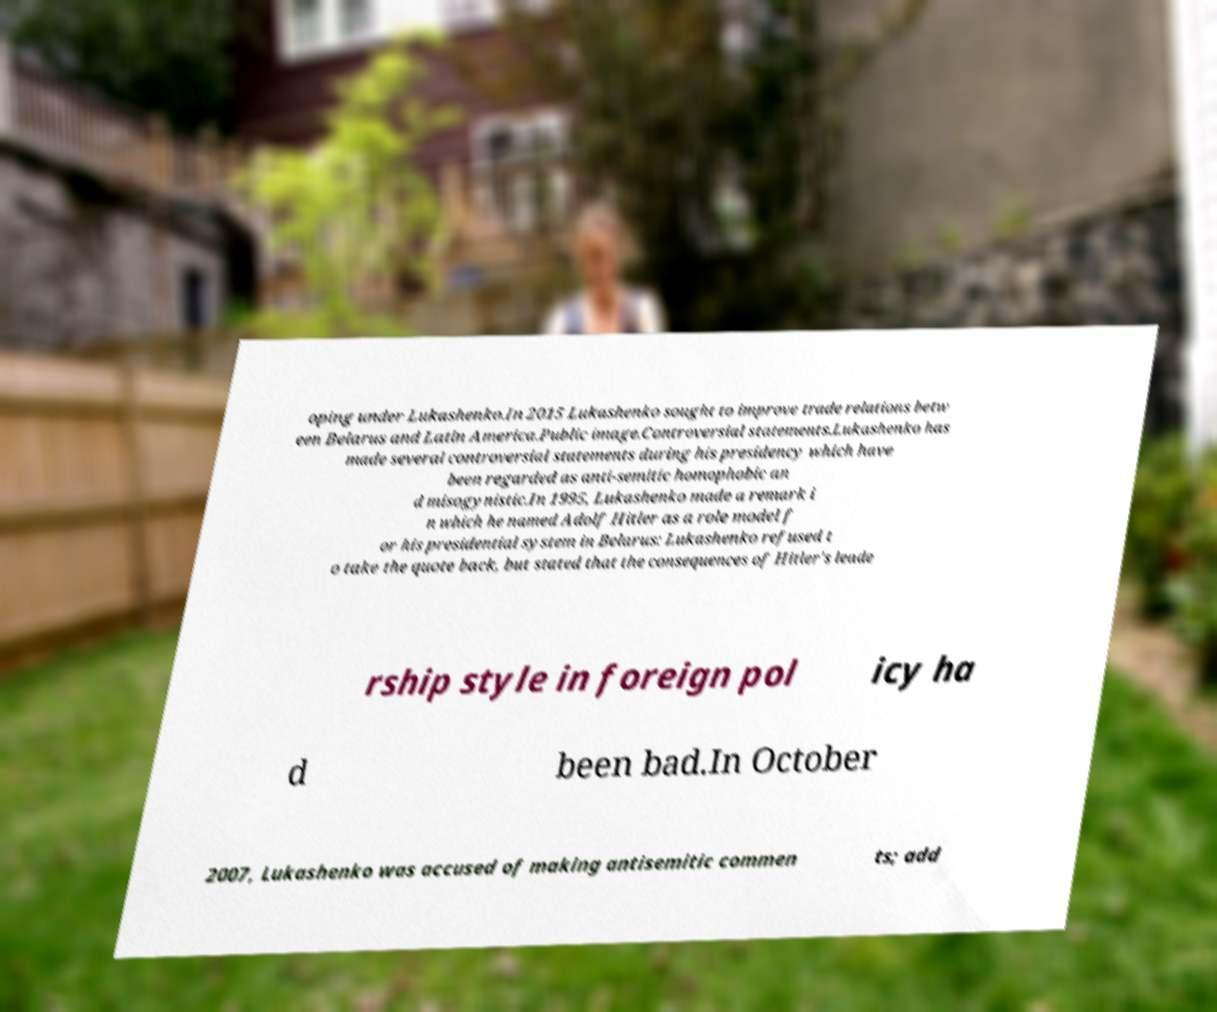Could you extract and type out the text from this image? oping under Lukashenko.In 2015 Lukashenko sought to improve trade relations betw een Belarus and Latin America.Public image.Controversial statements.Lukashenko has made several controversial statements during his presidency which have been regarded as anti-semitic homophobic an d misogynistic.In 1995, Lukashenko made a remark i n which he named Adolf Hitler as a role model f or his presidential system in Belarus: Lukashenko refused t o take the quote back, but stated that the consequences of Hitler's leade rship style in foreign pol icy ha d been bad.In October 2007, Lukashenko was accused of making antisemitic commen ts; add 